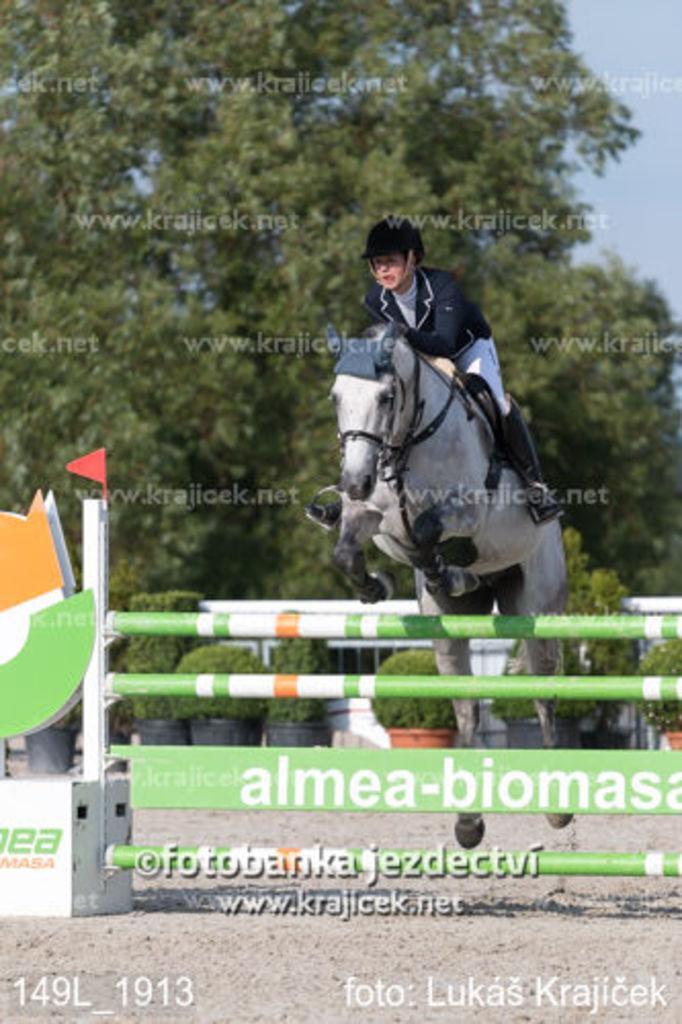Can you describe this image briefly? In this image, we can see a person sitting on the horse and wearing gloves, a helmet and a coat. In the background, there are trees and we can see plants, boards, railings, a flag and there is some text. 